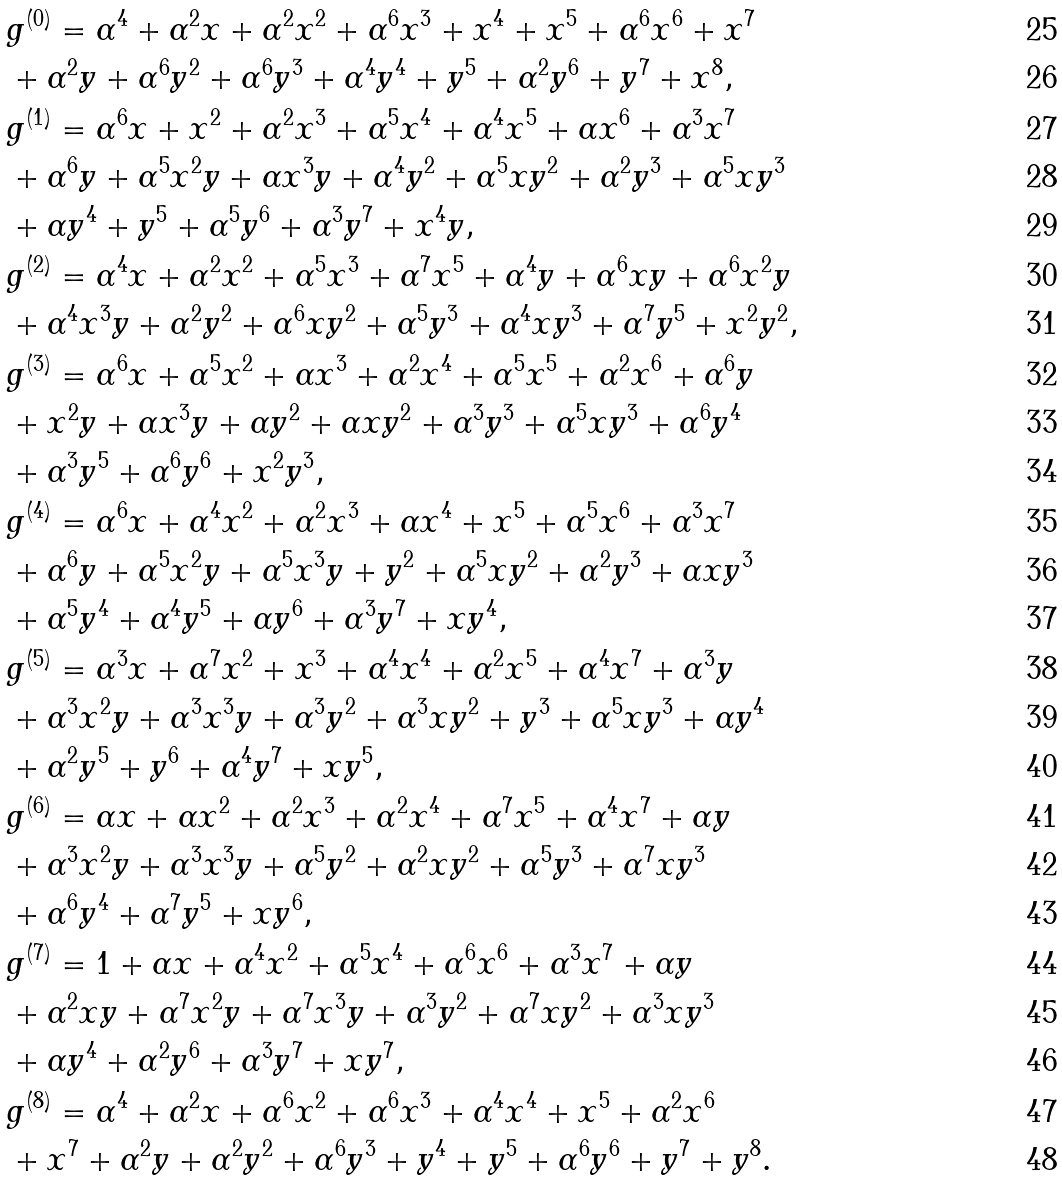<formula> <loc_0><loc_0><loc_500><loc_500>& g ^ { ( 0 ) } = \alpha ^ { 4 } + \alpha ^ { 2 } x + \alpha ^ { 2 } x ^ { 2 } + \alpha ^ { 6 } x ^ { 3 } + x ^ { 4 } + x ^ { 5 } + \alpha ^ { 6 } x ^ { 6 } + x ^ { 7 } \\ & + \alpha ^ { 2 } y + \alpha ^ { 6 } y ^ { 2 } + \alpha ^ { 6 } y ^ { 3 } + \alpha ^ { 4 } y ^ { 4 } + y ^ { 5 } + \alpha ^ { 2 } y ^ { 6 } + y ^ { 7 } + x ^ { 8 } , \\ & g ^ { ( 1 ) } = \alpha ^ { 6 } x + x ^ { 2 } + \alpha ^ { 2 } x ^ { 3 } + \alpha ^ { 5 } x ^ { 4 } + \alpha ^ { 4 } x ^ { 5 } + \alpha x ^ { 6 } + \alpha ^ { 3 } x ^ { 7 } \\ & + \alpha ^ { 6 } y + \alpha ^ { 5 } x ^ { 2 } y + \alpha x ^ { 3 } y + \alpha ^ { 4 } y ^ { 2 } + \alpha ^ { 5 } x y ^ { 2 } + \alpha ^ { 2 } y ^ { 3 } + \alpha ^ { 5 } x y ^ { 3 } \\ & + \alpha y ^ { 4 } + y ^ { 5 } + \alpha ^ { 5 } y ^ { 6 } + \alpha ^ { 3 } y ^ { 7 } + x ^ { 4 } y , \\ & g ^ { ( 2 ) } = \alpha ^ { 4 } x + \alpha ^ { 2 } x ^ { 2 } + \alpha ^ { 5 } x ^ { 3 } + \alpha ^ { 7 } x ^ { 5 } + \alpha ^ { 4 } y + \alpha ^ { 6 } x y + \alpha ^ { 6 } x ^ { 2 } y \\ & + \alpha ^ { 4 } x ^ { 3 } y + \alpha ^ { 2 } y ^ { 2 } + \alpha ^ { 6 } x y ^ { 2 } + \alpha ^ { 5 } y ^ { 3 } + \alpha ^ { 4 } x y ^ { 3 } + \alpha ^ { 7 } y ^ { 5 } + x ^ { 2 } y ^ { 2 } , \\ & g ^ { ( 3 ) } = \alpha ^ { 6 } x + \alpha ^ { 5 } x ^ { 2 } + \alpha x ^ { 3 } + \alpha ^ { 2 } x ^ { 4 } + \alpha ^ { 5 } x ^ { 5 } + \alpha ^ { 2 } x ^ { 6 } + \alpha ^ { 6 } y \\ & + x ^ { 2 } y + \alpha x ^ { 3 } y + \alpha y ^ { 2 } + \alpha x y ^ { 2 } + \alpha ^ { 3 } y ^ { 3 } + \alpha ^ { 5 } x y ^ { 3 } + \alpha ^ { 6 } y ^ { 4 } \\ & + \alpha ^ { 3 } y ^ { 5 } + \alpha ^ { 6 } y ^ { 6 } + x ^ { 2 } y ^ { 3 } , \\ & g ^ { ( 4 ) } = \alpha ^ { 6 } x + \alpha ^ { 4 } x ^ { 2 } + \alpha ^ { 2 } x ^ { 3 } + \alpha x ^ { 4 } + x ^ { 5 } + \alpha ^ { 5 } x ^ { 6 } + \alpha ^ { 3 } x ^ { 7 } \\ & + \alpha ^ { 6 } y + \alpha ^ { 5 } x ^ { 2 } y + \alpha ^ { 5 } x ^ { 3 } y + y ^ { 2 } + \alpha ^ { 5 } x y ^ { 2 } + \alpha ^ { 2 } y ^ { 3 } + \alpha x y ^ { 3 } \\ & + \alpha ^ { 5 } y ^ { 4 } + \alpha ^ { 4 } y ^ { 5 } + \alpha y ^ { 6 } + \alpha ^ { 3 } y ^ { 7 } + x y ^ { 4 } , \\ & g ^ { ( 5 ) } = \alpha ^ { 3 } x + \alpha ^ { 7 } x ^ { 2 } + x ^ { 3 } + \alpha ^ { 4 } x ^ { 4 } + \alpha ^ { 2 } x ^ { 5 } + \alpha ^ { 4 } x ^ { 7 } + \alpha ^ { 3 } y \\ & + \alpha ^ { 3 } x ^ { 2 } y + \alpha ^ { 3 } x ^ { 3 } y + \alpha ^ { 3 } y ^ { 2 } + \alpha ^ { 3 } x y ^ { 2 } + y ^ { 3 } + \alpha ^ { 5 } x y ^ { 3 } + \alpha y ^ { 4 } \\ & + \alpha ^ { 2 } y ^ { 5 } + y ^ { 6 } + \alpha ^ { 4 } y ^ { 7 } + x y ^ { 5 } , \\ & g ^ { ( 6 ) } = \alpha x + \alpha x ^ { 2 } + \alpha ^ { 2 } x ^ { 3 } + \alpha ^ { 2 } x ^ { 4 } + \alpha ^ { 7 } x ^ { 5 } + \alpha ^ { 4 } x ^ { 7 } + \alpha y \\ & + \alpha ^ { 3 } x ^ { 2 } y + \alpha ^ { 3 } x ^ { 3 } y + \alpha ^ { 5 } y ^ { 2 } + \alpha ^ { 2 } x y ^ { 2 } + \alpha ^ { 5 } y ^ { 3 } + \alpha ^ { 7 } x y ^ { 3 } \\ & + \alpha ^ { 6 } y ^ { 4 } + \alpha ^ { 7 } y ^ { 5 } + x y ^ { 6 } , \\ & g ^ { ( 7 ) } = 1 + \alpha x + \alpha ^ { 4 } x ^ { 2 } + \alpha ^ { 5 } x ^ { 4 } + \alpha ^ { 6 } x ^ { 6 } + \alpha ^ { 3 } x ^ { 7 } + \alpha y \\ & + \alpha ^ { 2 } x y + \alpha ^ { 7 } x ^ { 2 } y + \alpha ^ { 7 } x ^ { 3 } y + \alpha ^ { 3 } y ^ { 2 } + \alpha ^ { 7 } x y ^ { 2 } + \alpha ^ { 3 } x y ^ { 3 } \\ & + \alpha y ^ { 4 } + \alpha ^ { 2 } y ^ { 6 } + \alpha ^ { 3 } y ^ { 7 } + x y ^ { 7 } , \\ & g ^ { ( 8 ) } = \alpha ^ { 4 } + \alpha ^ { 2 } x + \alpha ^ { 6 } x ^ { 2 } + \alpha ^ { 6 } x ^ { 3 } + \alpha ^ { 4 } x ^ { 4 } + x ^ { 5 } + \alpha ^ { 2 } x ^ { 6 } \\ & + x ^ { 7 } + \alpha ^ { 2 } y + \alpha ^ { 2 } y ^ { 2 } + \alpha ^ { 6 } y ^ { 3 } + y ^ { 4 } + y ^ { 5 } + \alpha ^ { 6 } y ^ { 6 } + y ^ { 7 } + y ^ { 8 } .</formula> 